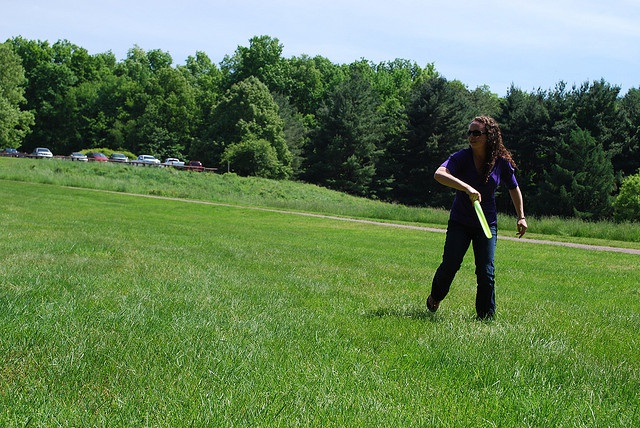Describe the objects in this image and their specific colors. I can see people in lavender, black, maroon, ivory, and navy tones, frisbee in lavender, lightyellow, khaki, and lightgreen tones, car in lavender, black, gray, and brown tones, car in lavender, white, darkgray, and gray tones, and car in lavender, white, blue, darkgray, and gray tones in this image. 